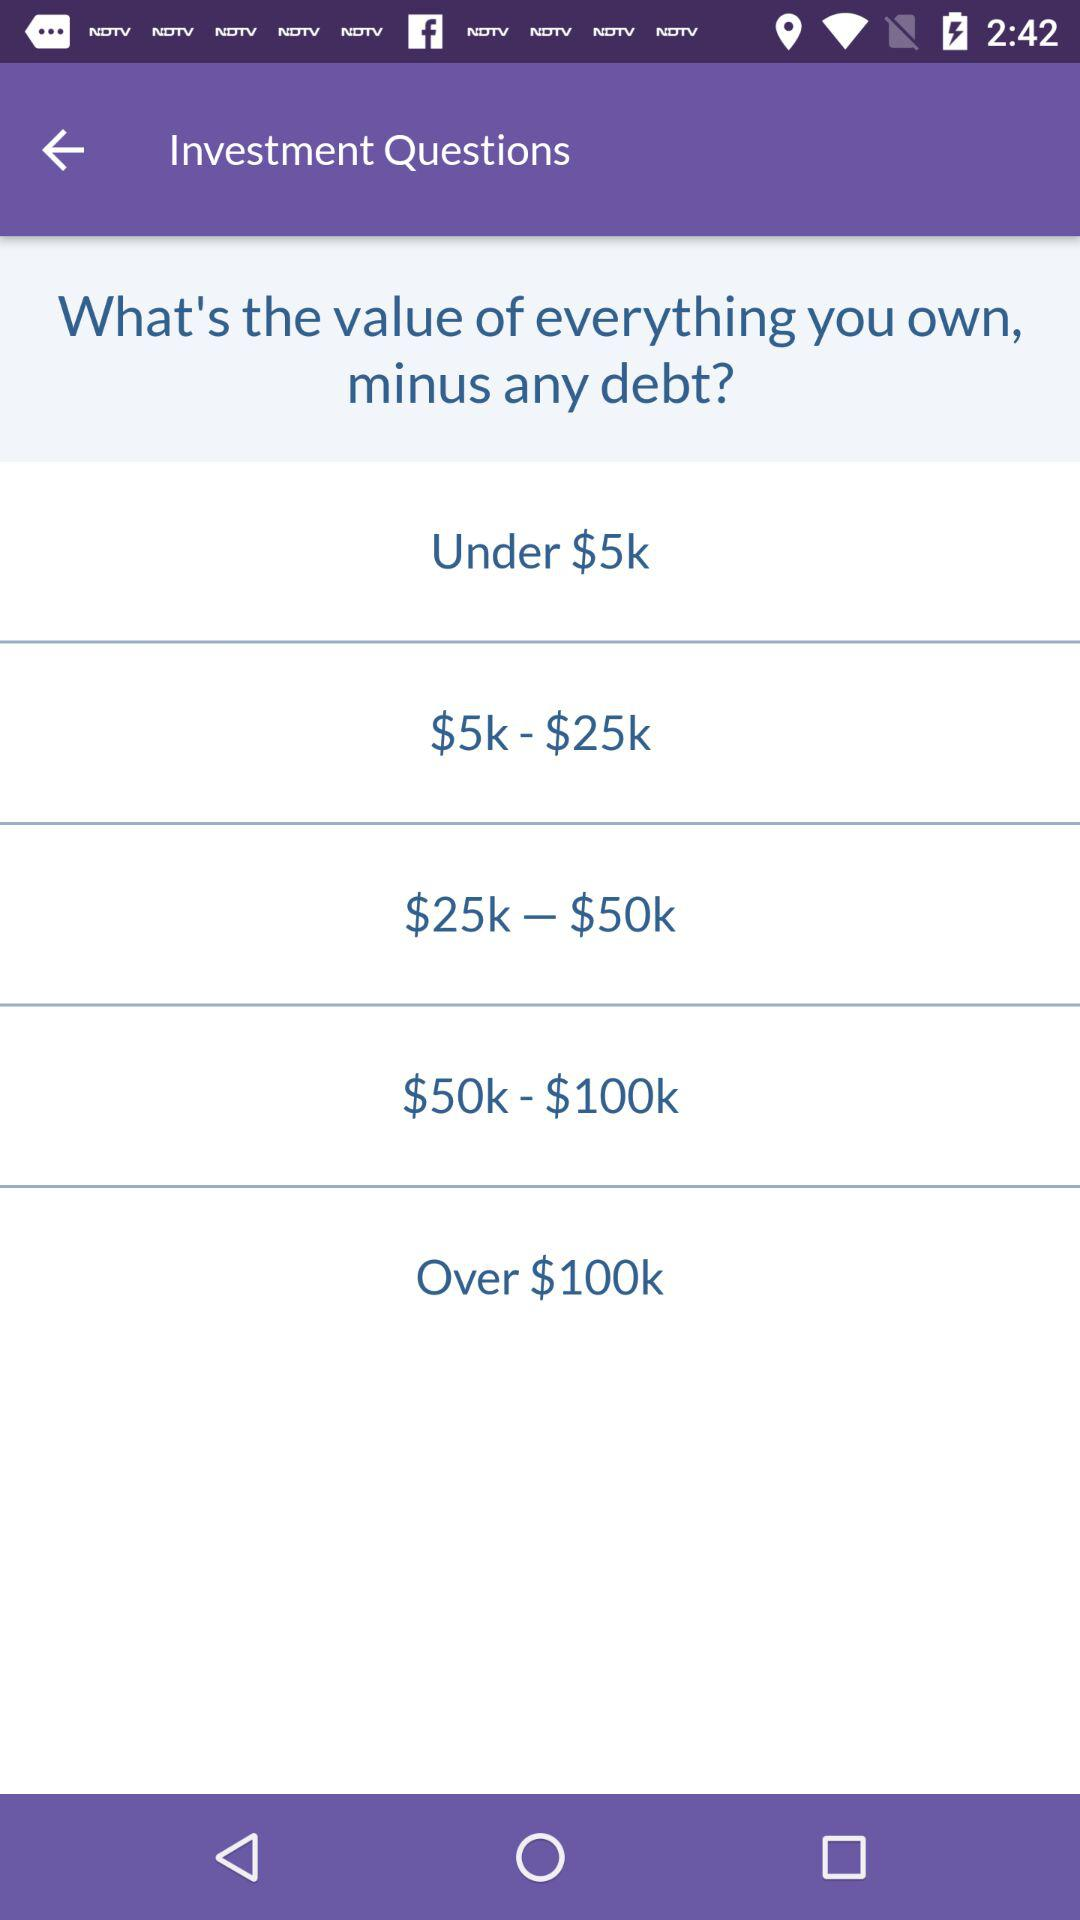How many options are there to choose from to answer the question?
Answer the question using a single word or phrase. 5 